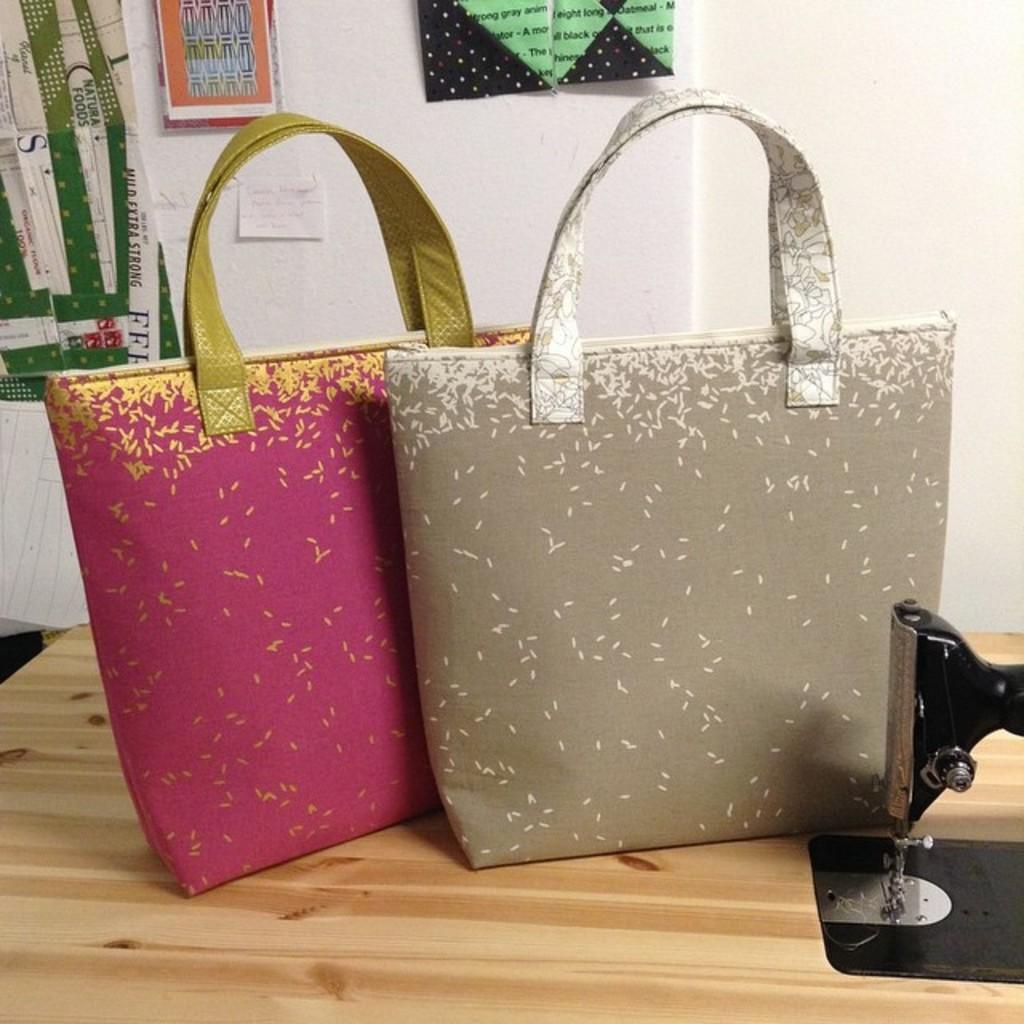How would you summarize this image in a sentence or two? In the middle of the image there are two bags on the table. Top of the image there is a wall, On the wall there are some posters. 